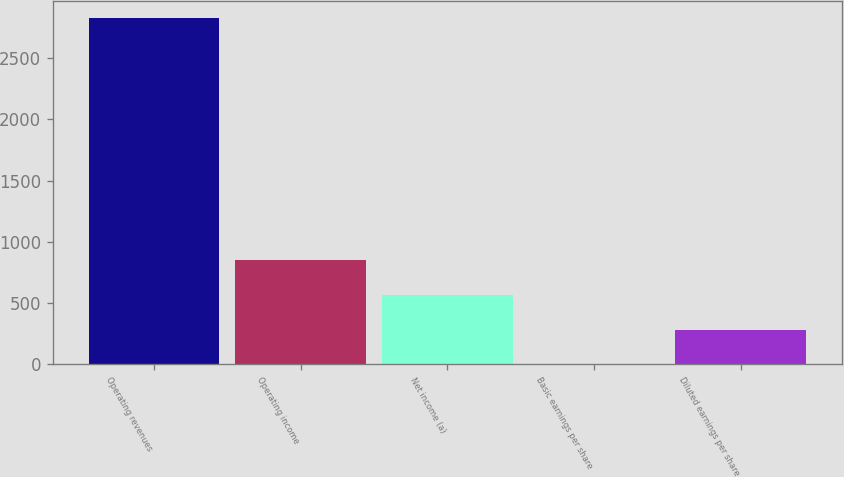<chart> <loc_0><loc_0><loc_500><loc_500><bar_chart><fcel>Operating revenues<fcel>Operating income<fcel>Net income (a)<fcel>Basic earnings per share<fcel>Diluted earnings per share<nl><fcel>2829<fcel>848.89<fcel>566.02<fcel>0.28<fcel>283.15<nl></chart> 